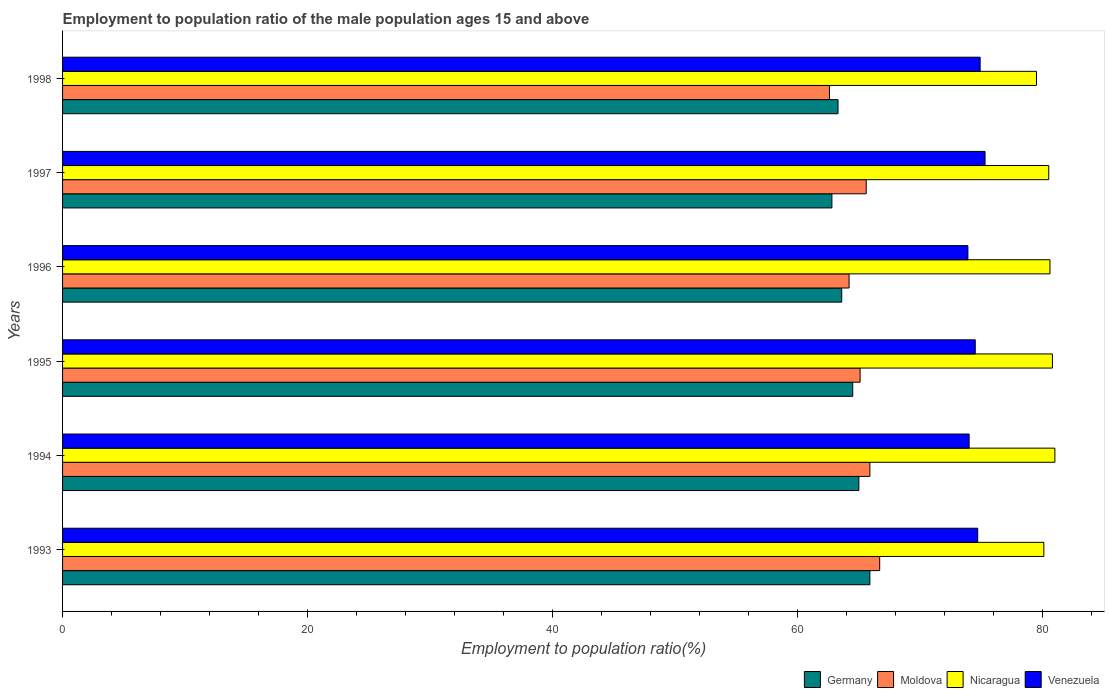How many different coloured bars are there?
Ensure brevity in your answer.  4. Are the number of bars per tick equal to the number of legend labels?
Offer a terse response. Yes. Are the number of bars on each tick of the Y-axis equal?
Ensure brevity in your answer.  Yes. How many bars are there on the 3rd tick from the top?
Keep it short and to the point. 4. How many bars are there on the 4th tick from the bottom?
Your answer should be compact. 4. In how many cases, is the number of bars for a given year not equal to the number of legend labels?
Your answer should be very brief. 0. What is the employment to population ratio in Moldova in 1996?
Your answer should be compact. 64.2. Across all years, what is the maximum employment to population ratio in Nicaragua?
Offer a terse response. 81. Across all years, what is the minimum employment to population ratio in Venezuela?
Give a very brief answer. 73.9. What is the total employment to population ratio in Venezuela in the graph?
Offer a terse response. 447.3. What is the difference between the employment to population ratio in Venezuela in 1993 and that in 1996?
Offer a terse response. 0.8. What is the difference between the employment to population ratio in Germany in 1994 and the employment to population ratio in Moldova in 1995?
Offer a terse response. -0.1. What is the average employment to population ratio in Venezuela per year?
Provide a succinct answer. 74.55. In the year 1995, what is the difference between the employment to population ratio in Moldova and employment to population ratio in Venezuela?
Offer a terse response. -9.4. In how many years, is the employment to population ratio in Venezuela greater than 60 %?
Offer a terse response. 6. What is the ratio of the employment to population ratio in Venezuela in 1995 to that in 1996?
Give a very brief answer. 1.01. What is the difference between the highest and the second highest employment to population ratio in Germany?
Offer a terse response. 0.9. What is the difference between the highest and the lowest employment to population ratio in Nicaragua?
Your answer should be very brief. 1.5. In how many years, is the employment to population ratio in Moldova greater than the average employment to population ratio in Moldova taken over all years?
Provide a succinct answer. 4. Is the sum of the employment to population ratio in Venezuela in 1994 and 1997 greater than the maximum employment to population ratio in Moldova across all years?
Make the answer very short. Yes. What does the 2nd bar from the top in 1996 represents?
Provide a short and direct response. Nicaragua. What does the 1st bar from the bottom in 1993 represents?
Provide a succinct answer. Germany. Is it the case that in every year, the sum of the employment to population ratio in Moldova and employment to population ratio in Germany is greater than the employment to population ratio in Venezuela?
Offer a terse response. Yes. How many bars are there?
Your answer should be compact. 24. How many years are there in the graph?
Offer a very short reply. 6. Are the values on the major ticks of X-axis written in scientific E-notation?
Provide a short and direct response. No. Does the graph contain any zero values?
Offer a terse response. No. Where does the legend appear in the graph?
Keep it short and to the point. Bottom right. What is the title of the graph?
Make the answer very short. Employment to population ratio of the male population ages 15 and above. What is the label or title of the X-axis?
Keep it short and to the point. Employment to population ratio(%). What is the Employment to population ratio(%) of Germany in 1993?
Give a very brief answer. 65.9. What is the Employment to population ratio(%) in Moldova in 1993?
Give a very brief answer. 66.7. What is the Employment to population ratio(%) of Nicaragua in 1993?
Make the answer very short. 80.1. What is the Employment to population ratio(%) of Venezuela in 1993?
Your answer should be very brief. 74.7. What is the Employment to population ratio(%) in Germany in 1994?
Ensure brevity in your answer.  65. What is the Employment to population ratio(%) in Moldova in 1994?
Keep it short and to the point. 65.9. What is the Employment to population ratio(%) in Germany in 1995?
Give a very brief answer. 64.5. What is the Employment to population ratio(%) in Moldova in 1995?
Your response must be concise. 65.1. What is the Employment to population ratio(%) of Nicaragua in 1995?
Offer a very short reply. 80.8. What is the Employment to population ratio(%) in Venezuela in 1995?
Your answer should be compact. 74.5. What is the Employment to population ratio(%) of Germany in 1996?
Keep it short and to the point. 63.6. What is the Employment to population ratio(%) in Moldova in 1996?
Keep it short and to the point. 64.2. What is the Employment to population ratio(%) of Nicaragua in 1996?
Offer a terse response. 80.6. What is the Employment to population ratio(%) of Venezuela in 1996?
Your answer should be compact. 73.9. What is the Employment to population ratio(%) in Germany in 1997?
Offer a terse response. 62.8. What is the Employment to population ratio(%) of Moldova in 1997?
Keep it short and to the point. 65.6. What is the Employment to population ratio(%) in Nicaragua in 1997?
Provide a short and direct response. 80.5. What is the Employment to population ratio(%) of Venezuela in 1997?
Your response must be concise. 75.3. What is the Employment to population ratio(%) in Germany in 1998?
Provide a short and direct response. 63.3. What is the Employment to population ratio(%) of Moldova in 1998?
Offer a terse response. 62.6. What is the Employment to population ratio(%) of Nicaragua in 1998?
Offer a terse response. 79.5. What is the Employment to population ratio(%) in Venezuela in 1998?
Offer a terse response. 74.9. Across all years, what is the maximum Employment to population ratio(%) in Germany?
Your response must be concise. 65.9. Across all years, what is the maximum Employment to population ratio(%) in Moldova?
Make the answer very short. 66.7. Across all years, what is the maximum Employment to population ratio(%) of Nicaragua?
Make the answer very short. 81. Across all years, what is the maximum Employment to population ratio(%) in Venezuela?
Provide a short and direct response. 75.3. Across all years, what is the minimum Employment to population ratio(%) of Germany?
Keep it short and to the point. 62.8. Across all years, what is the minimum Employment to population ratio(%) of Moldova?
Ensure brevity in your answer.  62.6. Across all years, what is the minimum Employment to population ratio(%) of Nicaragua?
Offer a very short reply. 79.5. Across all years, what is the minimum Employment to population ratio(%) in Venezuela?
Your answer should be compact. 73.9. What is the total Employment to population ratio(%) in Germany in the graph?
Your response must be concise. 385.1. What is the total Employment to population ratio(%) in Moldova in the graph?
Offer a very short reply. 390.1. What is the total Employment to population ratio(%) of Nicaragua in the graph?
Provide a succinct answer. 482.5. What is the total Employment to population ratio(%) in Venezuela in the graph?
Offer a terse response. 447.3. What is the difference between the Employment to population ratio(%) of Germany in 1993 and that in 1994?
Your answer should be compact. 0.9. What is the difference between the Employment to population ratio(%) of Moldova in 1993 and that in 1994?
Your response must be concise. 0.8. What is the difference between the Employment to population ratio(%) in Venezuela in 1993 and that in 1995?
Ensure brevity in your answer.  0.2. What is the difference between the Employment to population ratio(%) of Moldova in 1993 and that in 1996?
Your answer should be compact. 2.5. What is the difference between the Employment to population ratio(%) in Nicaragua in 1993 and that in 1996?
Keep it short and to the point. -0.5. What is the difference between the Employment to population ratio(%) of Nicaragua in 1993 and that in 1997?
Provide a short and direct response. -0.4. What is the difference between the Employment to population ratio(%) of Venezuela in 1993 and that in 1997?
Make the answer very short. -0.6. What is the difference between the Employment to population ratio(%) of Moldova in 1993 and that in 1998?
Your answer should be compact. 4.1. What is the difference between the Employment to population ratio(%) of Nicaragua in 1993 and that in 1998?
Your answer should be very brief. 0.6. What is the difference between the Employment to population ratio(%) in Venezuela in 1993 and that in 1998?
Your answer should be very brief. -0.2. What is the difference between the Employment to population ratio(%) of Germany in 1994 and that in 1995?
Your answer should be very brief. 0.5. What is the difference between the Employment to population ratio(%) of Moldova in 1994 and that in 1995?
Ensure brevity in your answer.  0.8. What is the difference between the Employment to population ratio(%) in Venezuela in 1994 and that in 1995?
Offer a very short reply. -0.5. What is the difference between the Employment to population ratio(%) in Germany in 1994 and that in 1996?
Provide a short and direct response. 1.4. What is the difference between the Employment to population ratio(%) in Moldova in 1994 and that in 1996?
Make the answer very short. 1.7. What is the difference between the Employment to population ratio(%) of Nicaragua in 1994 and that in 1996?
Provide a short and direct response. 0.4. What is the difference between the Employment to population ratio(%) of Venezuela in 1994 and that in 1996?
Offer a terse response. 0.1. What is the difference between the Employment to population ratio(%) in Moldova in 1994 and that in 1997?
Offer a terse response. 0.3. What is the difference between the Employment to population ratio(%) in Nicaragua in 1994 and that in 1997?
Make the answer very short. 0.5. What is the difference between the Employment to population ratio(%) in Venezuela in 1994 and that in 1997?
Provide a short and direct response. -1.3. What is the difference between the Employment to population ratio(%) in Moldova in 1994 and that in 1998?
Your response must be concise. 3.3. What is the difference between the Employment to population ratio(%) of Germany in 1995 and that in 1996?
Offer a very short reply. 0.9. What is the difference between the Employment to population ratio(%) of Moldova in 1995 and that in 1996?
Ensure brevity in your answer.  0.9. What is the difference between the Employment to population ratio(%) in Venezuela in 1995 and that in 1996?
Provide a short and direct response. 0.6. What is the difference between the Employment to population ratio(%) of Germany in 1995 and that in 1998?
Give a very brief answer. 1.2. What is the difference between the Employment to population ratio(%) of Moldova in 1995 and that in 1998?
Make the answer very short. 2.5. What is the difference between the Employment to population ratio(%) of Nicaragua in 1995 and that in 1998?
Give a very brief answer. 1.3. What is the difference between the Employment to population ratio(%) in Nicaragua in 1996 and that in 1997?
Your answer should be very brief. 0.1. What is the difference between the Employment to population ratio(%) in Venezuela in 1996 and that in 1997?
Your answer should be very brief. -1.4. What is the difference between the Employment to population ratio(%) in Moldova in 1996 and that in 1998?
Give a very brief answer. 1.6. What is the difference between the Employment to population ratio(%) in Nicaragua in 1996 and that in 1998?
Keep it short and to the point. 1.1. What is the difference between the Employment to population ratio(%) of Venezuela in 1996 and that in 1998?
Keep it short and to the point. -1. What is the difference between the Employment to population ratio(%) of Venezuela in 1997 and that in 1998?
Give a very brief answer. 0.4. What is the difference between the Employment to population ratio(%) in Germany in 1993 and the Employment to population ratio(%) in Nicaragua in 1994?
Provide a short and direct response. -15.1. What is the difference between the Employment to population ratio(%) of Germany in 1993 and the Employment to population ratio(%) of Venezuela in 1994?
Ensure brevity in your answer.  -8.1. What is the difference between the Employment to population ratio(%) in Moldova in 1993 and the Employment to population ratio(%) in Nicaragua in 1994?
Keep it short and to the point. -14.3. What is the difference between the Employment to population ratio(%) of Moldova in 1993 and the Employment to population ratio(%) of Venezuela in 1994?
Provide a short and direct response. -7.3. What is the difference between the Employment to population ratio(%) of Nicaragua in 1993 and the Employment to population ratio(%) of Venezuela in 1994?
Make the answer very short. 6.1. What is the difference between the Employment to population ratio(%) of Germany in 1993 and the Employment to population ratio(%) of Moldova in 1995?
Make the answer very short. 0.8. What is the difference between the Employment to population ratio(%) of Germany in 1993 and the Employment to population ratio(%) of Nicaragua in 1995?
Your answer should be very brief. -14.9. What is the difference between the Employment to population ratio(%) of Moldova in 1993 and the Employment to population ratio(%) of Nicaragua in 1995?
Give a very brief answer. -14.1. What is the difference between the Employment to population ratio(%) in Nicaragua in 1993 and the Employment to population ratio(%) in Venezuela in 1995?
Ensure brevity in your answer.  5.6. What is the difference between the Employment to population ratio(%) of Germany in 1993 and the Employment to population ratio(%) of Moldova in 1996?
Keep it short and to the point. 1.7. What is the difference between the Employment to population ratio(%) of Germany in 1993 and the Employment to population ratio(%) of Nicaragua in 1996?
Provide a succinct answer. -14.7. What is the difference between the Employment to population ratio(%) of Germany in 1993 and the Employment to population ratio(%) of Venezuela in 1996?
Give a very brief answer. -8. What is the difference between the Employment to population ratio(%) in Moldova in 1993 and the Employment to population ratio(%) in Venezuela in 1996?
Provide a succinct answer. -7.2. What is the difference between the Employment to population ratio(%) of Germany in 1993 and the Employment to population ratio(%) of Moldova in 1997?
Your answer should be very brief. 0.3. What is the difference between the Employment to population ratio(%) of Germany in 1993 and the Employment to population ratio(%) of Nicaragua in 1997?
Offer a terse response. -14.6. What is the difference between the Employment to population ratio(%) of Germany in 1993 and the Employment to population ratio(%) of Venezuela in 1997?
Your response must be concise. -9.4. What is the difference between the Employment to population ratio(%) in Moldova in 1993 and the Employment to population ratio(%) in Nicaragua in 1997?
Provide a short and direct response. -13.8. What is the difference between the Employment to population ratio(%) in Nicaragua in 1993 and the Employment to population ratio(%) in Venezuela in 1997?
Make the answer very short. 4.8. What is the difference between the Employment to population ratio(%) in Germany in 1993 and the Employment to population ratio(%) in Moldova in 1998?
Your answer should be compact. 3.3. What is the difference between the Employment to population ratio(%) in Germany in 1993 and the Employment to population ratio(%) in Venezuela in 1998?
Offer a terse response. -9. What is the difference between the Employment to population ratio(%) in Moldova in 1993 and the Employment to population ratio(%) in Venezuela in 1998?
Your answer should be compact. -8.2. What is the difference between the Employment to population ratio(%) in Nicaragua in 1993 and the Employment to population ratio(%) in Venezuela in 1998?
Provide a short and direct response. 5.2. What is the difference between the Employment to population ratio(%) of Germany in 1994 and the Employment to population ratio(%) of Nicaragua in 1995?
Keep it short and to the point. -15.8. What is the difference between the Employment to population ratio(%) in Moldova in 1994 and the Employment to population ratio(%) in Nicaragua in 1995?
Offer a terse response. -14.9. What is the difference between the Employment to population ratio(%) in Nicaragua in 1994 and the Employment to population ratio(%) in Venezuela in 1995?
Provide a short and direct response. 6.5. What is the difference between the Employment to population ratio(%) of Germany in 1994 and the Employment to population ratio(%) of Nicaragua in 1996?
Keep it short and to the point. -15.6. What is the difference between the Employment to population ratio(%) of Germany in 1994 and the Employment to population ratio(%) of Venezuela in 1996?
Your response must be concise. -8.9. What is the difference between the Employment to population ratio(%) of Moldova in 1994 and the Employment to population ratio(%) of Nicaragua in 1996?
Offer a very short reply. -14.7. What is the difference between the Employment to population ratio(%) of Germany in 1994 and the Employment to population ratio(%) of Moldova in 1997?
Your answer should be very brief. -0.6. What is the difference between the Employment to population ratio(%) in Germany in 1994 and the Employment to population ratio(%) in Nicaragua in 1997?
Your response must be concise. -15.5. What is the difference between the Employment to population ratio(%) of Moldova in 1994 and the Employment to population ratio(%) of Nicaragua in 1997?
Offer a very short reply. -14.6. What is the difference between the Employment to population ratio(%) of Germany in 1994 and the Employment to population ratio(%) of Moldova in 1998?
Offer a terse response. 2.4. What is the difference between the Employment to population ratio(%) in Moldova in 1994 and the Employment to population ratio(%) in Nicaragua in 1998?
Provide a short and direct response. -13.6. What is the difference between the Employment to population ratio(%) in Moldova in 1994 and the Employment to population ratio(%) in Venezuela in 1998?
Give a very brief answer. -9. What is the difference between the Employment to population ratio(%) of Germany in 1995 and the Employment to population ratio(%) of Nicaragua in 1996?
Your answer should be compact. -16.1. What is the difference between the Employment to population ratio(%) in Moldova in 1995 and the Employment to population ratio(%) in Nicaragua in 1996?
Provide a short and direct response. -15.5. What is the difference between the Employment to population ratio(%) in Moldova in 1995 and the Employment to population ratio(%) in Venezuela in 1996?
Your answer should be compact. -8.8. What is the difference between the Employment to population ratio(%) of Germany in 1995 and the Employment to population ratio(%) of Moldova in 1997?
Your response must be concise. -1.1. What is the difference between the Employment to population ratio(%) of Germany in 1995 and the Employment to population ratio(%) of Nicaragua in 1997?
Keep it short and to the point. -16. What is the difference between the Employment to population ratio(%) of Moldova in 1995 and the Employment to population ratio(%) of Nicaragua in 1997?
Ensure brevity in your answer.  -15.4. What is the difference between the Employment to population ratio(%) in Germany in 1995 and the Employment to population ratio(%) in Venezuela in 1998?
Your answer should be very brief. -10.4. What is the difference between the Employment to population ratio(%) of Moldova in 1995 and the Employment to population ratio(%) of Nicaragua in 1998?
Provide a short and direct response. -14.4. What is the difference between the Employment to population ratio(%) in Moldova in 1995 and the Employment to population ratio(%) in Venezuela in 1998?
Keep it short and to the point. -9.8. What is the difference between the Employment to population ratio(%) in Germany in 1996 and the Employment to population ratio(%) in Nicaragua in 1997?
Your answer should be very brief. -16.9. What is the difference between the Employment to population ratio(%) of Moldova in 1996 and the Employment to population ratio(%) of Nicaragua in 1997?
Give a very brief answer. -16.3. What is the difference between the Employment to population ratio(%) of Moldova in 1996 and the Employment to population ratio(%) of Venezuela in 1997?
Give a very brief answer. -11.1. What is the difference between the Employment to population ratio(%) of Nicaragua in 1996 and the Employment to population ratio(%) of Venezuela in 1997?
Your answer should be compact. 5.3. What is the difference between the Employment to population ratio(%) of Germany in 1996 and the Employment to population ratio(%) of Moldova in 1998?
Offer a terse response. 1. What is the difference between the Employment to population ratio(%) in Germany in 1996 and the Employment to population ratio(%) in Nicaragua in 1998?
Offer a very short reply. -15.9. What is the difference between the Employment to population ratio(%) of Germany in 1996 and the Employment to population ratio(%) of Venezuela in 1998?
Give a very brief answer. -11.3. What is the difference between the Employment to population ratio(%) of Moldova in 1996 and the Employment to population ratio(%) of Nicaragua in 1998?
Provide a short and direct response. -15.3. What is the difference between the Employment to population ratio(%) of Germany in 1997 and the Employment to population ratio(%) of Moldova in 1998?
Your response must be concise. 0.2. What is the difference between the Employment to population ratio(%) of Germany in 1997 and the Employment to population ratio(%) of Nicaragua in 1998?
Make the answer very short. -16.7. What is the difference between the Employment to population ratio(%) in Moldova in 1997 and the Employment to population ratio(%) in Venezuela in 1998?
Provide a short and direct response. -9.3. What is the average Employment to population ratio(%) of Germany per year?
Offer a terse response. 64.18. What is the average Employment to population ratio(%) of Moldova per year?
Your response must be concise. 65.02. What is the average Employment to population ratio(%) in Nicaragua per year?
Give a very brief answer. 80.42. What is the average Employment to population ratio(%) of Venezuela per year?
Provide a succinct answer. 74.55. In the year 1993, what is the difference between the Employment to population ratio(%) in Germany and Employment to population ratio(%) in Moldova?
Your answer should be very brief. -0.8. In the year 1993, what is the difference between the Employment to population ratio(%) in Germany and Employment to population ratio(%) in Venezuela?
Offer a very short reply. -8.8. In the year 1993, what is the difference between the Employment to population ratio(%) in Moldova and Employment to population ratio(%) in Nicaragua?
Your response must be concise. -13.4. In the year 1993, what is the difference between the Employment to population ratio(%) in Moldova and Employment to population ratio(%) in Venezuela?
Provide a short and direct response. -8. In the year 1994, what is the difference between the Employment to population ratio(%) of Germany and Employment to population ratio(%) of Venezuela?
Give a very brief answer. -9. In the year 1994, what is the difference between the Employment to population ratio(%) of Moldova and Employment to population ratio(%) of Nicaragua?
Ensure brevity in your answer.  -15.1. In the year 1995, what is the difference between the Employment to population ratio(%) of Germany and Employment to population ratio(%) of Moldova?
Make the answer very short. -0.6. In the year 1995, what is the difference between the Employment to population ratio(%) in Germany and Employment to population ratio(%) in Nicaragua?
Your response must be concise. -16.3. In the year 1995, what is the difference between the Employment to population ratio(%) in Moldova and Employment to population ratio(%) in Nicaragua?
Provide a succinct answer. -15.7. In the year 1995, what is the difference between the Employment to population ratio(%) in Moldova and Employment to population ratio(%) in Venezuela?
Offer a very short reply. -9.4. In the year 1996, what is the difference between the Employment to population ratio(%) of Germany and Employment to population ratio(%) of Moldova?
Ensure brevity in your answer.  -0.6. In the year 1996, what is the difference between the Employment to population ratio(%) of Germany and Employment to population ratio(%) of Nicaragua?
Your answer should be very brief. -17. In the year 1996, what is the difference between the Employment to population ratio(%) of Moldova and Employment to population ratio(%) of Nicaragua?
Keep it short and to the point. -16.4. In the year 1996, what is the difference between the Employment to population ratio(%) of Nicaragua and Employment to population ratio(%) of Venezuela?
Your answer should be very brief. 6.7. In the year 1997, what is the difference between the Employment to population ratio(%) in Germany and Employment to population ratio(%) in Moldova?
Your answer should be compact. -2.8. In the year 1997, what is the difference between the Employment to population ratio(%) in Germany and Employment to population ratio(%) in Nicaragua?
Your response must be concise. -17.7. In the year 1997, what is the difference between the Employment to population ratio(%) of Germany and Employment to population ratio(%) of Venezuela?
Your answer should be compact. -12.5. In the year 1997, what is the difference between the Employment to population ratio(%) of Moldova and Employment to population ratio(%) of Nicaragua?
Offer a terse response. -14.9. In the year 1998, what is the difference between the Employment to population ratio(%) in Germany and Employment to population ratio(%) in Moldova?
Provide a short and direct response. 0.7. In the year 1998, what is the difference between the Employment to population ratio(%) in Germany and Employment to population ratio(%) in Nicaragua?
Make the answer very short. -16.2. In the year 1998, what is the difference between the Employment to population ratio(%) in Moldova and Employment to population ratio(%) in Nicaragua?
Provide a short and direct response. -16.9. In the year 1998, what is the difference between the Employment to population ratio(%) in Moldova and Employment to population ratio(%) in Venezuela?
Your answer should be compact. -12.3. What is the ratio of the Employment to population ratio(%) in Germany in 1993 to that in 1994?
Offer a very short reply. 1.01. What is the ratio of the Employment to population ratio(%) in Moldova in 1993 to that in 1994?
Ensure brevity in your answer.  1.01. What is the ratio of the Employment to population ratio(%) in Nicaragua in 1993 to that in 1994?
Offer a terse response. 0.99. What is the ratio of the Employment to population ratio(%) of Venezuela in 1993 to that in 1994?
Provide a succinct answer. 1.01. What is the ratio of the Employment to population ratio(%) in Germany in 1993 to that in 1995?
Offer a very short reply. 1.02. What is the ratio of the Employment to population ratio(%) in Moldova in 1993 to that in 1995?
Give a very brief answer. 1.02. What is the ratio of the Employment to population ratio(%) of Germany in 1993 to that in 1996?
Make the answer very short. 1.04. What is the ratio of the Employment to population ratio(%) in Moldova in 1993 to that in 1996?
Your answer should be very brief. 1.04. What is the ratio of the Employment to population ratio(%) of Venezuela in 1993 to that in 1996?
Your answer should be compact. 1.01. What is the ratio of the Employment to population ratio(%) in Germany in 1993 to that in 1997?
Your answer should be very brief. 1.05. What is the ratio of the Employment to population ratio(%) in Moldova in 1993 to that in 1997?
Your response must be concise. 1.02. What is the ratio of the Employment to population ratio(%) of Venezuela in 1993 to that in 1997?
Offer a very short reply. 0.99. What is the ratio of the Employment to population ratio(%) in Germany in 1993 to that in 1998?
Your response must be concise. 1.04. What is the ratio of the Employment to population ratio(%) of Moldova in 1993 to that in 1998?
Make the answer very short. 1.07. What is the ratio of the Employment to population ratio(%) in Nicaragua in 1993 to that in 1998?
Offer a terse response. 1.01. What is the ratio of the Employment to population ratio(%) of Venezuela in 1993 to that in 1998?
Keep it short and to the point. 1. What is the ratio of the Employment to population ratio(%) in Moldova in 1994 to that in 1995?
Offer a terse response. 1.01. What is the ratio of the Employment to population ratio(%) of Nicaragua in 1994 to that in 1995?
Offer a terse response. 1. What is the ratio of the Employment to population ratio(%) in Venezuela in 1994 to that in 1995?
Provide a short and direct response. 0.99. What is the ratio of the Employment to population ratio(%) in Germany in 1994 to that in 1996?
Make the answer very short. 1.02. What is the ratio of the Employment to population ratio(%) in Moldova in 1994 to that in 1996?
Make the answer very short. 1.03. What is the ratio of the Employment to population ratio(%) of Nicaragua in 1994 to that in 1996?
Your response must be concise. 1. What is the ratio of the Employment to population ratio(%) in Germany in 1994 to that in 1997?
Offer a very short reply. 1.03. What is the ratio of the Employment to population ratio(%) of Moldova in 1994 to that in 1997?
Keep it short and to the point. 1. What is the ratio of the Employment to population ratio(%) in Nicaragua in 1994 to that in 1997?
Your response must be concise. 1.01. What is the ratio of the Employment to population ratio(%) in Venezuela in 1994 to that in 1997?
Your response must be concise. 0.98. What is the ratio of the Employment to population ratio(%) of Germany in 1994 to that in 1998?
Provide a succinct answer. 1.03. What is the ratio of the Employment to population ratio(%) of Moldova in 1994 to that in 1998?
Offer a very short reply. 1.05. What is the ratio of the Employment to population ratio(%) of Nicaragua in 1994 to that in 1998?
Your answer should be compact. 1.02. What is the ratio of the Employment to population ratio(%) in Germany in 1995 to that in 1996?
Ensure brevity in your answer.  1.01. What is the ratio of the Employment to population ratio(%) in Nicaragua in 1995 to that in 1996?
Provide a short and direct response. 1. What is the ratio of the Employment to population ratio(%) of Venezuela in 1995 to that in 1996?
Make the answer very short. 1.01. What is the ratio of the Employment to population ratio(%) of Germany in 1995 to that in 1997?
Offer a terse response. 1.03. What is the ratio of the Employment to population ratio(%) of Germany in 1995 to that in 1998?
Your answer should be compact. 1.02. What is the ratio of the Employment to population ratio(%) in Moldova in 1995 to that in 1998?
Your response must be concise. 1.04. What is the ratio of the Employment to population ratio(%) in Nicaragua in 1995 to that in 1998?
Offer a very short reply. 1.02. What is the ratio of the Employment to population ratio(%) of Germany in 1996 to that in 1997?
Your response must be concise. 1.01. What is the ratio of the Employment to population ratio(%) of Moldova in 1996 to that in 1997?
Your answer should be compact. 0.98. What is the ratio of the Employment to population ratio(%) in Nicaragua in 1996 to that in 1997?
Ensure brevity in your answer.  1. What is the ratio of the Employment to population ratio(%) in Venezuela in 1996 to that in 1997?
Your response must be concise. 0.98. What is the ratio of the Employment to population ratio(%) of Germany in 1996 to that in 1998?
Make the answer very short. 1. What is the ratio of the Employment to population ratio(%) in Moldova in 1996 to that in 1998?
Your answer should be very brief. 1.03. What is the ratio of the Employment to population ratio(%) of Nicaragua in 1996 to that in 1998?
Ensure brevity in your answer.  1.01. What is the ratio of the Employment to population ratio(%) in Venezuela in 1996 to that in 1998?
Keep it short and to the point. 0.99. What is the ratio of the Employment to population ratio(%) of Moldova in 1997 to that in 1998?
Provide a short and direct response. 1.05. What is the ratio of the Employment to population ratio(%) of Nicaragua in 1997 to that in 1998?
Your answer should be compact. 1.01. What is the difference between the highest and the second highest Employment to population ratio(%) of Nicaragua?
Offer a very short reply. 0.2. What is the difference between the highest and the lowest Employment to population ratio(%) in Moldova?
Provide a short and direct response. 4.1. What is the difference between the highest and the lowest Employment to population ratio(%) in Nicaragua?
Your answer should be compact. 1.5. What is the difference between the highest and the lowest Employment to population ratio(%) of Venezuela?
Make the answer very short. 1.4. 